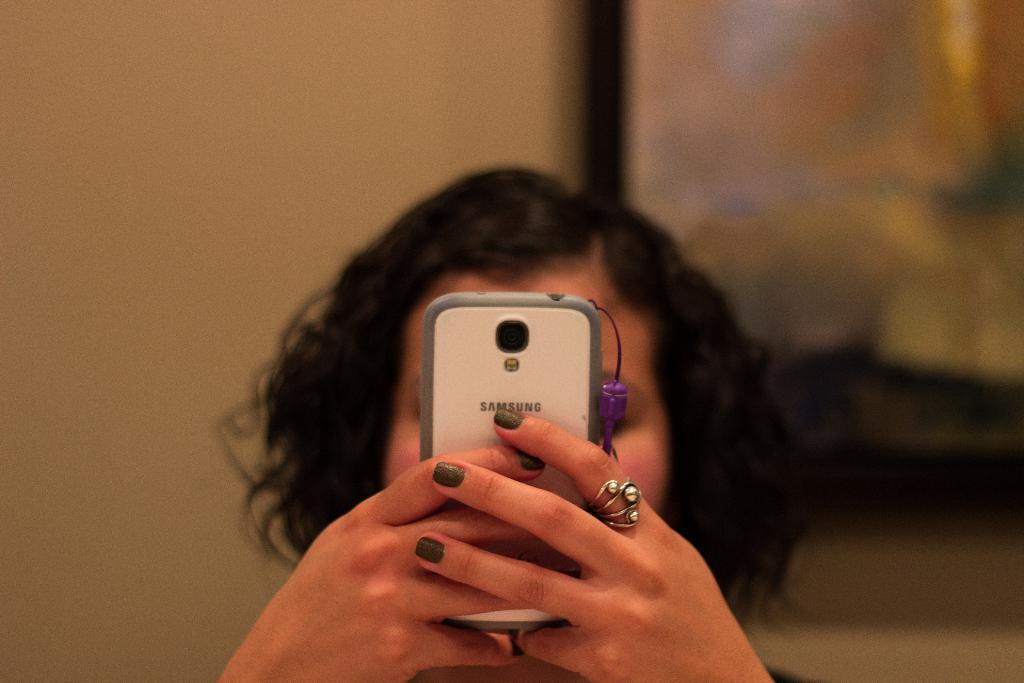Who is the main subject in the image? There is a woman in the image. What is the woman wearing on her finger? The woman is wearing a ring on her finger. What is the woman holding in the image? The woman is holding a mobile with both hands. Can you describe the background of the image? The background of the image is blurred. How many rabbits can be seen in the image? There are no rabbits present in the image. What type of feather is the woman using to write on the mobile? There is no feather visible in the image, and the woman is not writing on the mobile. 